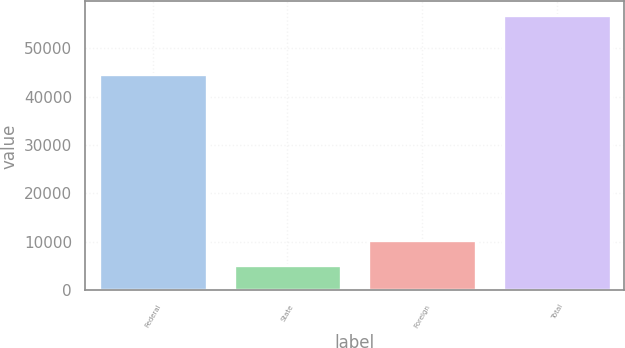Convert chart to OTSL. <chart><loc_0><loc_0><loc_500><loc_500><bar_chart><fcel>Federal<fcel>State<fcel>Foreign<fcel>Total<nl><fcel>44736<fcel>5253<fcel>10413.9<fcel>56862<nl></chart> 